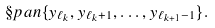<formula> <loc_0><loc_0><loc_500><loc_500>\S p a n \{ y _ { \ell _ { k } } , y _ { \ell _ { k } + 1 } , \dots , y _ { \ell _ { k + 1 } - 1 } \} .</formula> 